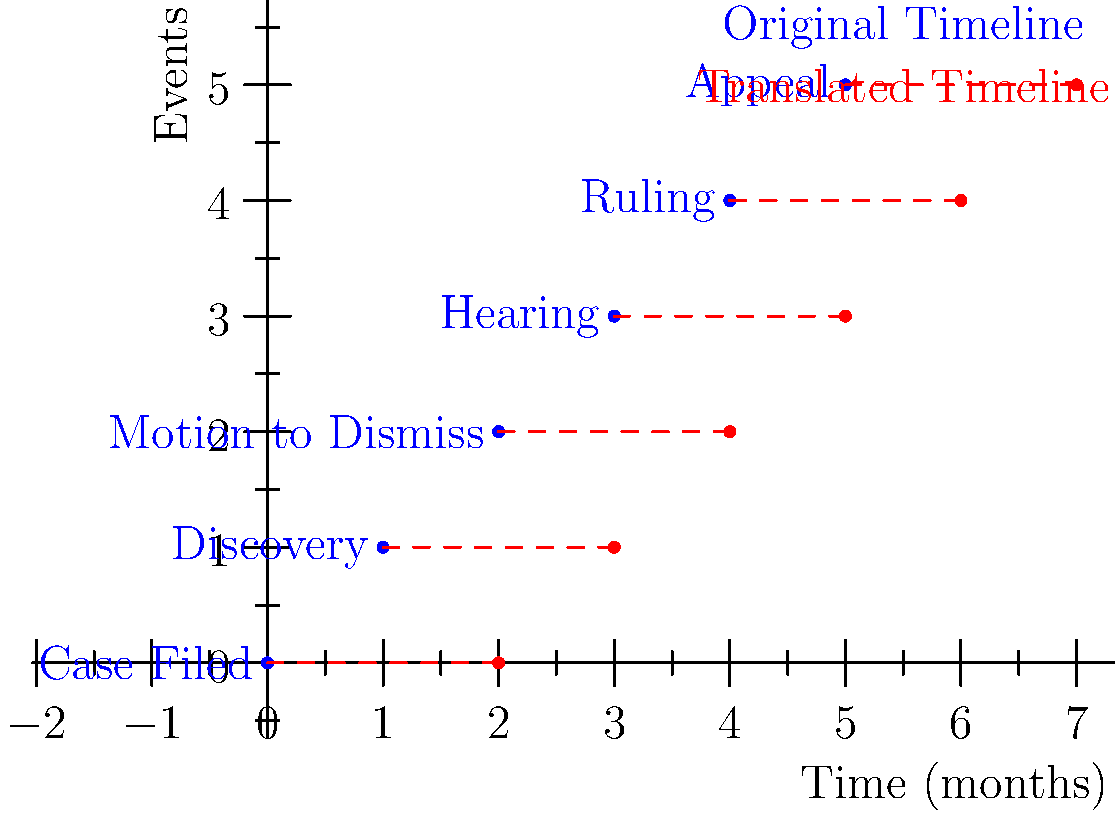In the diagram, a timeline of legal events has been translated to the right by 2 months. How does this translation affect the interpretation of cause and effect relationships between events, and what potential impact could this have on your preparation of motions? To understand the impact of this translation on cause and effect relationships and motion preparation:

1. Observe the original timeline (blue dots):
   - Events occur at 0, 1, 2, 3, 4, and 5 months.

2. Identify the translation:
   - All events are shifted 2 months to the right (red dots).

3. Analyze the effect on cause and effect relationships:
   a) Relative timing remains the same:
      - The order of events is preserved.
      - Time intervals between events are unchanged.
   b) Absolute timing is altered:
      - Each event now occurs 2 months later than originally scheduled.

4. Consider the impact on motion preparation:
   a) Deadlines:
      - All deadlines would be pushed back by 2 months.
      - This affects filing dates for motions and responses.
   b) Argument strategy:
      - The additional time might allow for more thorough research and preparation.
      - It could also provide opportunities for new developments or evidence to emerge.
   c) Procedural considerations:
      - The translation might affect statutory time limits or court-imposed deadlines.
      - You may need to file motions for extensions or adjustments to the court calendar.

5. Potential benefits and challenges:
   - Benefit: More time for case development and strategic planning.
   - Challenge: Possible delays in resolution and increased costs for clients.

6. Motion content:
   - Motions might need to address the reasons for the timeline shift.
   - Arguments could incorporate any new information gained during the additional time.

In conclusion, while the cause and effect relationships between events remain intact, the absolute timing shift requires careful consideration in motion preparation, deadline management, and overall case strategy.
Answer: Preserved relative timing, shifted absolute dates; adjust motion deadlines, strategy, and content accordingly. 